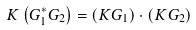Convert formula to latex. <formula><loc_0><loc_0><loc_500><loc_500>K \left ( G _ { 1 } ^ { * } G _ { 2 } \right ) = \left ( K G _ { 1 } \right ) \cdot \left ( K G _ { 2 } \right )</formula> 